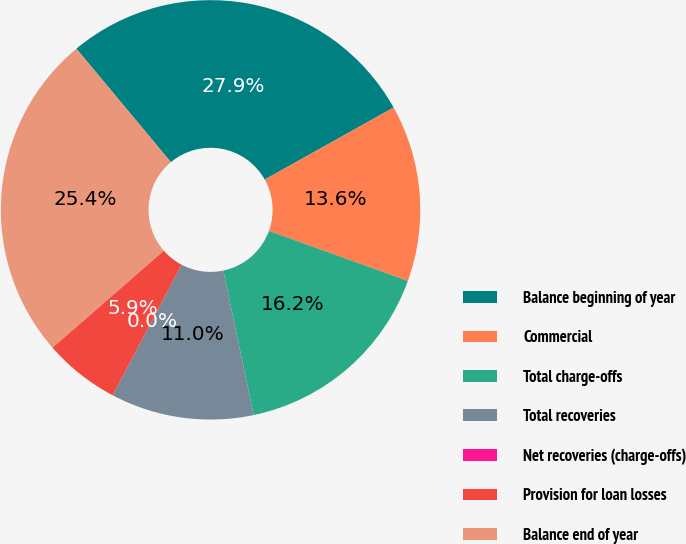Convert chart. <chart><loc_0><loc_0><loc_500><loc_500><pie_chart><fcel>Balance beginning of year<fcel>Commercial<fcel>Total charge-offs<fcel>Total recoveries<fcel>Net recoveries (charge-offs)<fcel>Provision for loan losses<fcel>Balance end of year<nl><fcel>27.94%<fcel>13.62%<fcel>16.2%<fcel>11.03%<fcel>0.0%<fcel>5.86%<fcel>25.36%<nl></chart> 